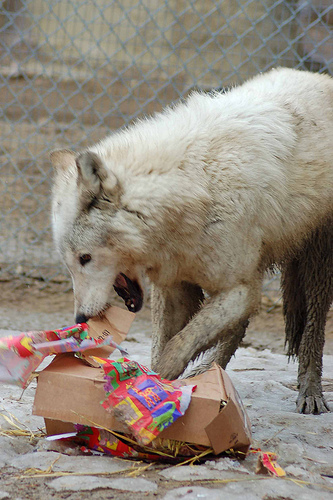<image>
Is the dog on the fence? No. The dog is not positioned on the fence. They may be near each other, but the dog is not supported by or resting on top of the fence. 